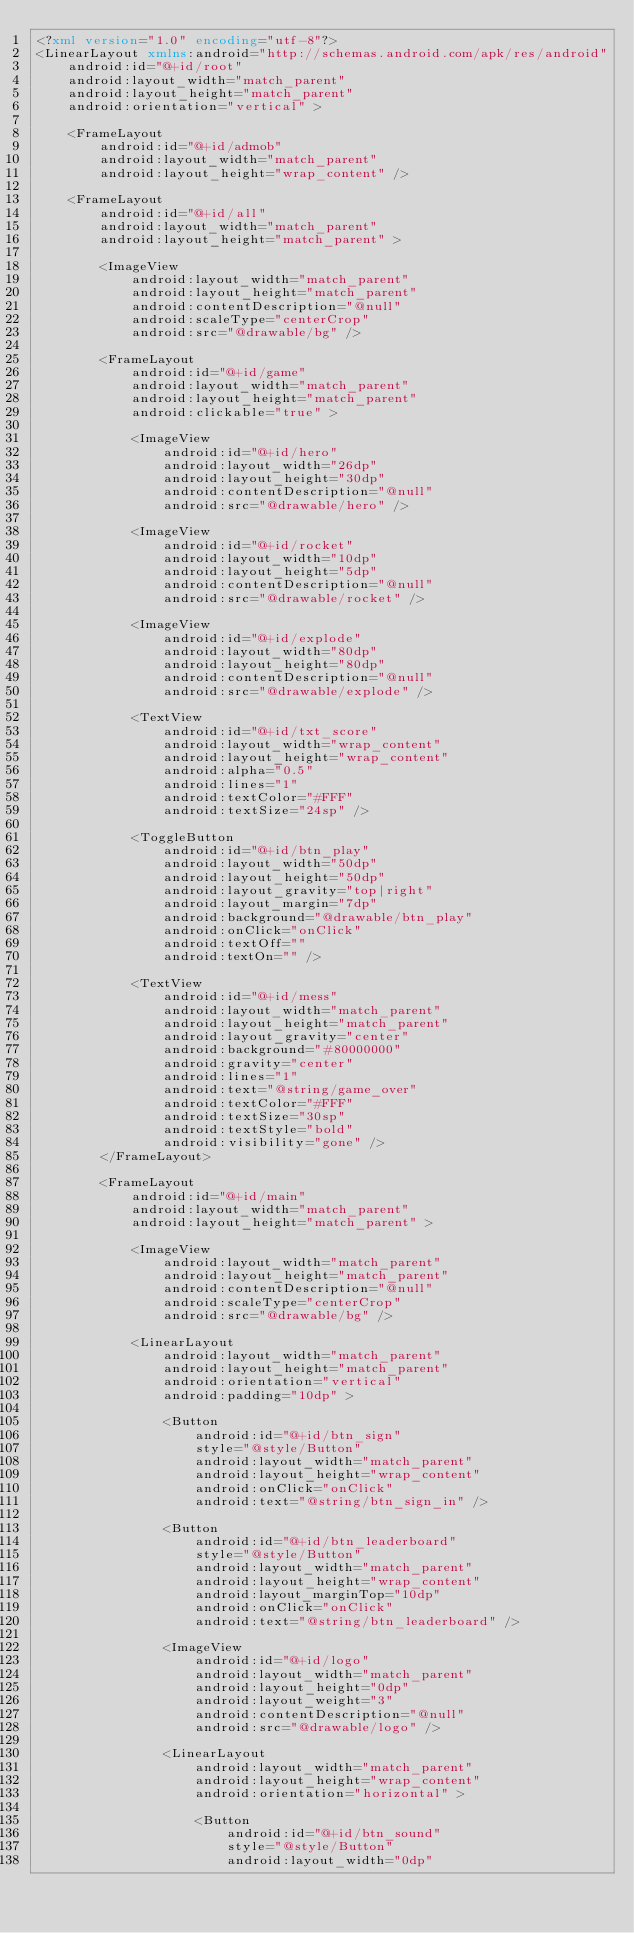Convert code to text. <code><loc_0><loc_0><loc_500><loc_500><_XML_><?xml version="1.0" encoding="utf-8"?>
<LinearLayout xmlns:android="http://schemas.android.com/apk/res/android"
    android:id="@+id/root"
    android:layout_width="match_parent"
    android:layout_height="match_parent"
    android:orientation="vertical" >

    <FrameLayout
        android:id="@+id/admob"
        android:layout_width="match_parent"
        android:layout_height="wrap_content" />

    <FrameLayout
        android:id="@+id/all"
        android:layout_width="match_parent"
        android:layout_height="match_parent" >

        <ImageView
            android:layout_width="match_parent"
            android:layout_height="match_parent"
            android:contentDescription="@null"
            android:scaleType="centerCrop"
            android:src="@drawable/bg" />

        <FrameLayout
            android:id="@+id/game"
            android:layout_width="match_parent"
            android:layout_height="match_parent"
            android:clickable="true" >

            <ImageView
                android:id="@+id/hero"
                android:layout_width="26dp"
                android:layout_height="30dp"
                android:contentDescription="@null"
                android:src="@drawable/hero" />

            <ImageView
                android:id="@+id/rocket"
                android:layout_width="10dp"
                android:layout_height="5dp"
                android:contentDescription="@null"
                android:src="@drawable/rocket" />

            <ImageView
                android:id="@+id/explode"
                android:layout_width="80dp"
                android:layout_height="80dp"
                android:contentDescription="@null"
                android:src="@drawable/explode" />

            <TextView
                android:id="@+id/txt_score"
                android:layout_width="wrap_content"
                android:layout_height="wrap_content"
                android:alpha="0.5"
                android:lines="1"
                android:textColor="#FFF"
                android:textSize="24sp" />

            <ToggleButton
                android:id="@+id/btn_play"
                android:layout_width="50dp"
                android:layout_height="50dp"
                android:layout_gravity="top|right"
                android:layout_margin="7dp"
                android:background="@drawable/btn_play"
                android:onClick="onClick"
                android:textOff=""
                android:textOn="" />

            <TextView
                android:id="@+id/mess"
                android:layout_width="match_parent"
                android:layout_height="match_parent"
                android:layout_gravity="center"
                android:background="#80000000"
                android:gravity="center"
                android:lines="1"
                android:text="@string/game_over"
                android:textColor="#FFF"
                android:textSize="30sp"
                android:textStyle="bold"
                android:visibility="gone" />
        </FrameLayout>

        <FrameLayout
            android:id="@+id/main"
            android:layout_width="match_parent"
            android:layout_height="match_parent" >

            <ImageView
                android:layout_width="match_parent"
                android:layout_height="match_parent"
                android:contentDescription="@null"
                android:scaleType="centerCrop"
                android:src="@drawable/bg" />

            <LinearLayout
                android:layout_width="match_parent"
                android:layout_height="match_parent"
                android:orientation="vertical"
                android:padding="10dp" >

                <Button
                    android:id="@+id/btn_sign"
                    style="@style/Button"
                    android:layout_width="match_parent"
                    android:layout_height="wrap_content"
                    android:onClick="onClick"
                    android:text="@string/btn_sign_in" />

                <Button
                    android:id="@+id/btn_leaderboard"
                    style="@style/Button"
                    android:layout_width="match_parent"
                    android:layout_height="wrap_content"
                    android:layout_marginTop="10dp"
                    android:onClick="onClick"
                    android:text="@string/btn_leaderboard" />

                <ImageView
                    android:id="@+id/logo"
                    android:layout_width="match_parent"
                    android:layout_height="0dp"
                    android:layout_weight="3"
                    android:contentDescription="@null"
                    android:src="@drawable/logo" />

                <LinearLayout
                    android:layout_width="match_parent"
                    android:layout_height="wrap_content"
                    android:orientation="horizontal" >

                    <Button
                        android:id="@+id/btn_sound"
                        style="@style/Button"
                        android:layout_width="0dp"</code> 